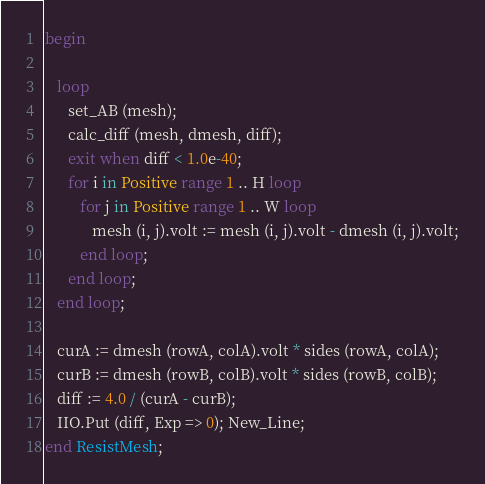Convert code to text. <code><loc_0><loc_0><loc_500><loc_500><_Ada_>
begin

   loop
      set_AB (mesh);
      calc_diff (mesh, dmesh, diff);
      exit when diff < 1.0e-40;
      for i in Positive range 1 .. H loop
         for j in Positive range 1 .. W loop
            mesh (i, j).volt := mesh (i, j).volt - dmesh (i, j).volt;
         end loop;
      end loop;
   end loop;

   curA := dmesh (rowA, colA).volt * sides (rowA, colA);
   curB := dmesh (rowB, colB).volt * sides (rowB, colB);
   diff := 4.0 / (curA - curB);
   IIO.Put (diff, Exp => 0); New_Line;
end ResistMesh;
</code> 